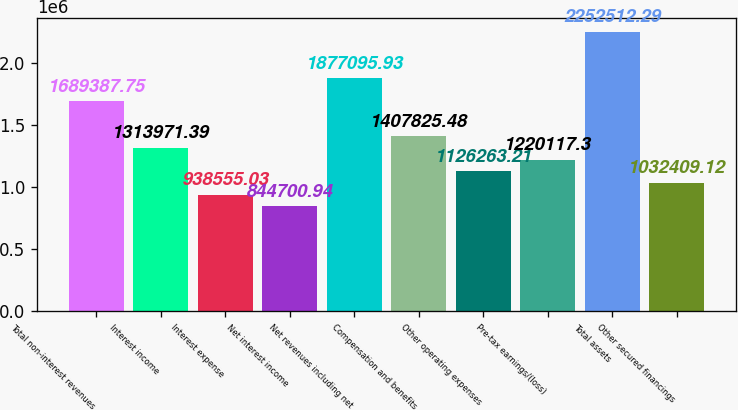Convert chart to OTSL. <chart><loc_0><loc_0><loc_500><loc_500><bar_chart><fcel>Total non-interest revenues<fcel>Interest income<fcel>Interest expense<fcel>Net interest income<fcel>Net revenues including net<fcel>Compensation and benefits<fcel>Other operating expenses<fcel>Pre-tax earnings/(loss)<fcel>Total assets<fcel>Other secured financings<nl><fcel>1.68939e+06<fcel>1.31397e+06<fcel>938555<fcel>844701<fcel>1.8771e+06<fcel>1.40783e+06<fcel>1.12626e+06<fcel>1.22012e+06<fcel>2.25251e+06<fcel>1.03241e+06<nl></chart> 